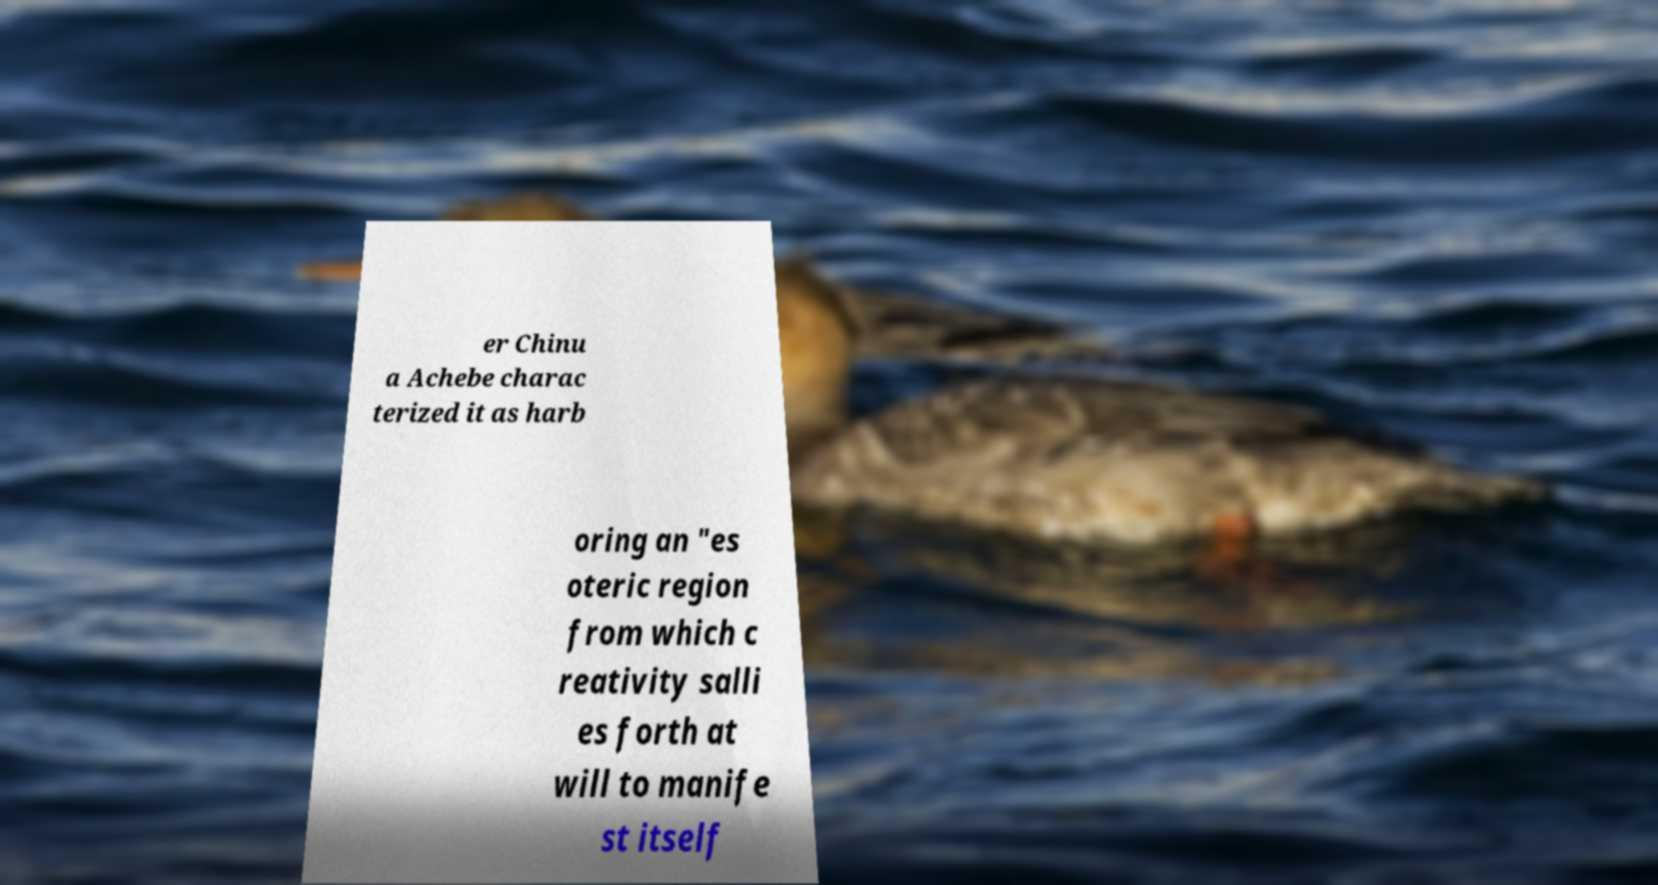Can you read and provide the text displayed in the image?This photo seems to have some interesting text. Can you extract and type it out for me? er Chinu a Achebe charac terized it as harb oring an "es oteric region from which c reativity salli es forth at will to manife st itself 